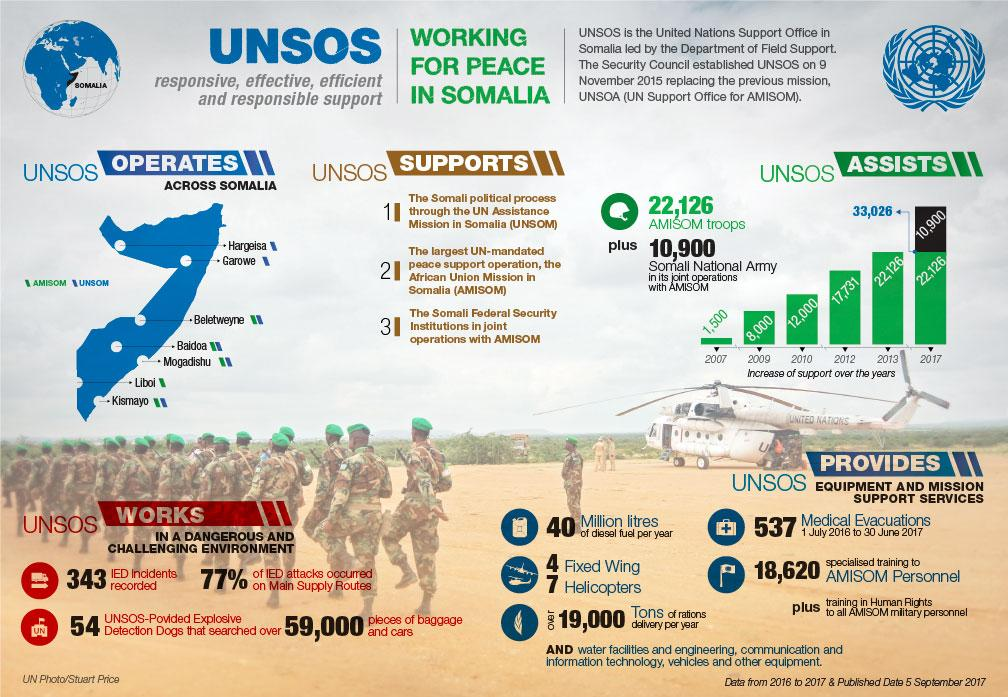Identify some key points in this picture. In 2010, the UNSOS deployed 12,000 troops for the AMISOM mission. The United Nations Support Office in Somalia (UNSOS) has deployed a total of 33,026 personnel as part of the African Union Mission in Somalia (AMISOM) mission. During the period of 1 July 2016 to 30 June 2017, a total of 537 medical evacuations were conducted with support from the United Nations Stabilization Operations Service (UNSOS). The United Nations Stabilization Mission in Haiti (UNSOS) provides approximately 40 million liters of diesel fuel per year. In 2017, the Somali National Army conducted joint operations with the African Union Mission in Somalia (AMISOM). 